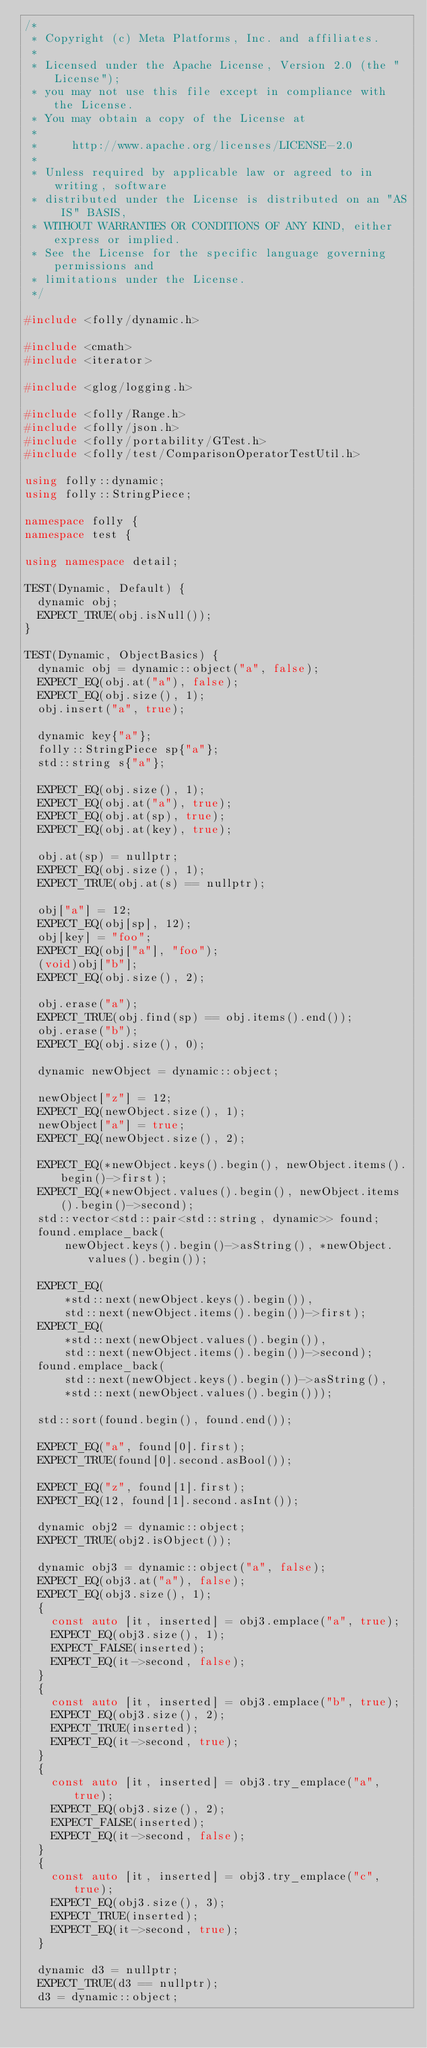Convert code to text. <code><loc_0><loc_0><loc_500><loc_500><_C++_>/*
 * Copyright (c) Meta Platforms, Inc. and affiliates.
 *
 * Licensed under the Apache License, Version 2.0 (the "License");
 * you may not use this file except in compliance with the License.
 * You may obtain a copy of the License at
 *
 *     http://www.apache.org/licenses/LICENSE-2.0
 *
 * Unless required by applicable law or agreed to in writing, software
 * distributed under the License is distributed on an "AS IS" BASIS,
 * WITHOUT WARRANTIES OR CONDITIONS OF ANY KIND, either express or implied.
 * See the License for the specific language governing permissions and
 * limitations under the License.
 */

#include <folly/dynamic.h>

#include <cmath>
#include <iterator>

#include <glog/logging.h>

#include <folly/Range.h>
#include <folly/json.h>
#include <folly/portability/GTest.h>
#include <folly/test/ComparisonOperatorTestUtil.h>

using folly::dynamic;
using folly::StringPiece;

namespace folly {
namespace test {

using namespace detail;

TEST(Dynamic, Default) {
  dynamic obj;
  EXPECT_TRUE(obj.isNull());
}

TEST(Dynamic, ObjectBasics) {
  dynamic obj = dynamic::object("a", false);
  EXPECT_EQ(obj.at("a"), false);
  EXPECT_EQ(obj.size(), 1);
  obj.insert("a", true);

  dynamic key{"a"};
  folly::StringPiece sp{"a"};
  std::string s{"a"};

  EXPECT_EQ(obj.size(), 1);
  EXPECT_EQ(obj.at("a"), true);
  EXPECT_EQ(obj.at(sp), true);
  EXPECT_EQ(obj.at(key), true);

  obj.at(sp) = nullptr;
  EXPECT_EQ(obj.size(), 1);
  EXPECT_TRUE(obj.at(s) == nullptr);

  obj["a"] = 12;
  EXPECT_EQ(obj[sp], 12);
  obj[key] = "foo";
  EXPECT_EQ(obj["a"], "foo");
  (void)obj["b"];
  EXPECT_EQ(obj.size(), 2);

  obj.erase("a");
  EXPECT_TRUE(obj.find(sp) == obj.items().end());
  obj.erase("b");
  EXPECT_EQ(obj.size(), 0);

  dynamic newObject = dynamic::object;

  newObject["z"] = 12;
  EXPECT_EQ(newObject.size(), 1);
  newObject["a"] = true;
  EXPECT_EQ(newObject.size(), 2);

  EXPECT_EQ(*newObject.keys().begin(), newObject.items().begin()->first);
  EXPECT_EQ(*newObject.values().begin(), newObject.items().begin()->second);
  std::vector<std::pair<std::string, dynamic>> found;
  found.emplace_back(
      newObject.keys().begin()->asString(), *newObject.values().begin());

  EXPECT_EQ(
      *std::next(newObject.keys().begin()),
      std::next(newObject.items().begin())->first);
  EXPECT_EQ(
      *std::next(newObject.values().begin()),
      std::next(newObject.items().begin())->second);
  found.emplace_back(
      std::next(newObject.keys().begin())->asString(),
      *std::next(newObject.values().begin()));

  std::sort(found.begin(), found.end());

  EXPECT_EQ("a", found[0].first);
  EXPECT_TRUE(found[0].second.asBool());

  EXPECT_EQ("z", found[1].first);
  EXPECT_EQ(12, found[1].second.asInt());

  dynamic obj2 = dynamic::object;
  EXPECT_TRUE(obj2.isObject());

  dynamic obj3 = dynamic::object("a", false);
  EXPECT_EQ(obj3.at("a"), false);
  EXPECT_EQ(obj3.size(), 1);
  {
    const auto [it, inserted] = obj3.emplace("a", true);
    EXPECT_EQ(obj3.size(), 1);
    EXPECT_FALSE(inserted);
    EXPECT_EQ(it->second, false);
  }
  {
    const auto [it, inserted] = obj3.emplace("b", true);
    EXPECT_EQ(obj3.size(), 2);
    EXPECT_TRUE(inserted);
    EXPECT_EQ(it->second, true);
  }
  {
    const auto [it, inserted] = obj3.try_emplace("a", true);
    EXPECT_EQ(obj3.size(), 2);
    EXPECT_FALSE(inserted);
    EXPECT_EQ(it->second, false);
  }
  {
    const auto [it, inserted] = obj3.try_emplace("c", true);
    EXPECT_EQ(obj3.size(), 3);
    EXPECT_TRUE(inserted);
    EXPECT_EQ(it->second, true);
  }

  dynamic d3 = nullptr;
  EXPECT_TRUE(d3 == nullptr);
  d3 = dynamic::object;</code> 